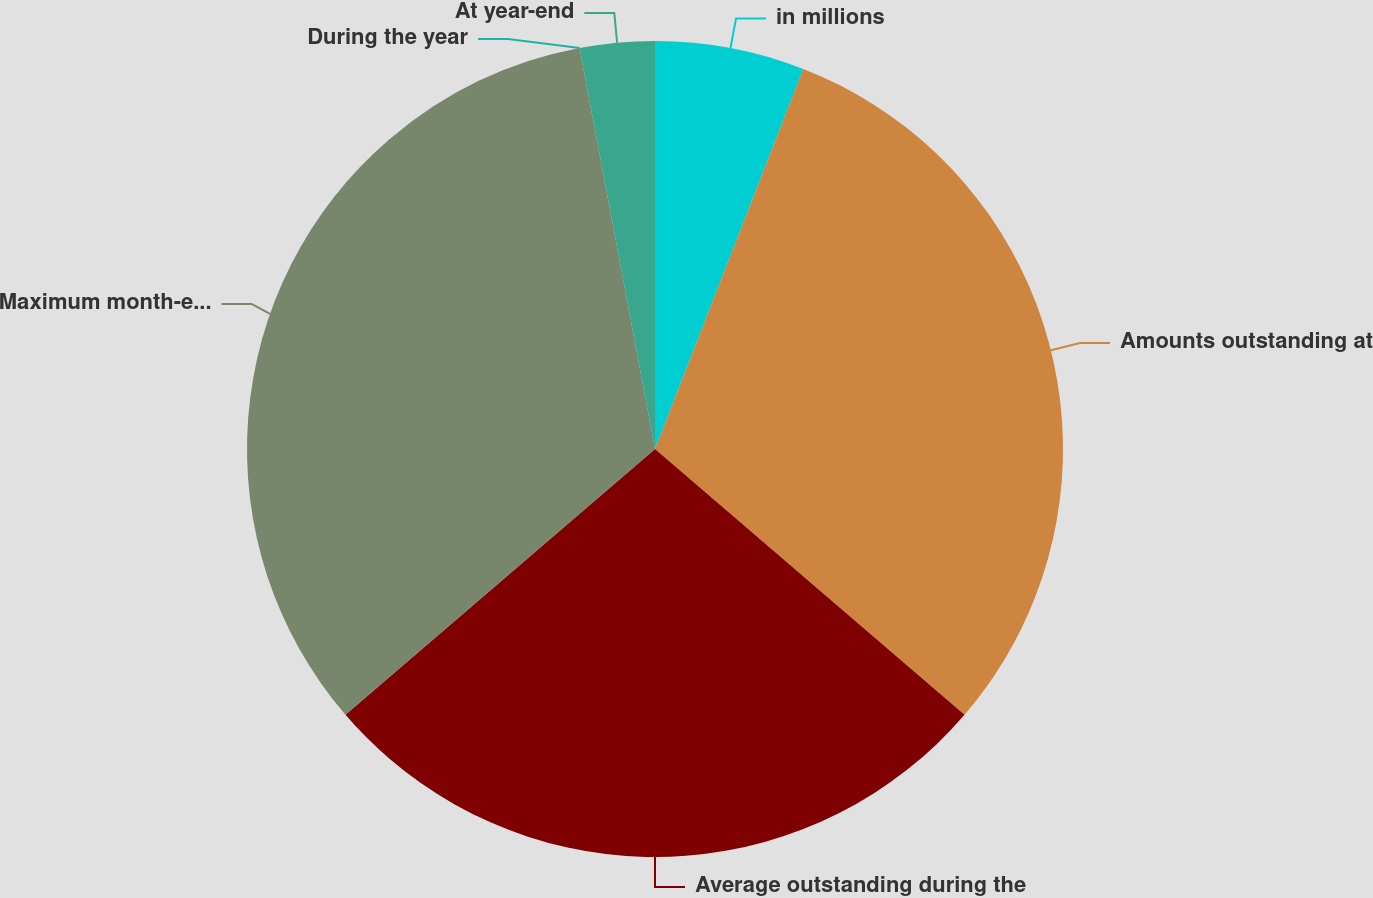<chart> <loc_0><loc_0><loc_500><loc_500><pie_chart><fcel>in millions<fcel>Amounts outstanding at<fcel>Average outstanding during the<fcel>Maximum month-end outstanding<fcel>During the year<fcel>At year-end<nl><fcel>5.92%<fcel>30.37%<fcel>27.41%<fcel>33.33%<fcel>0.0%<fcel>2.96%<nl></chart> 